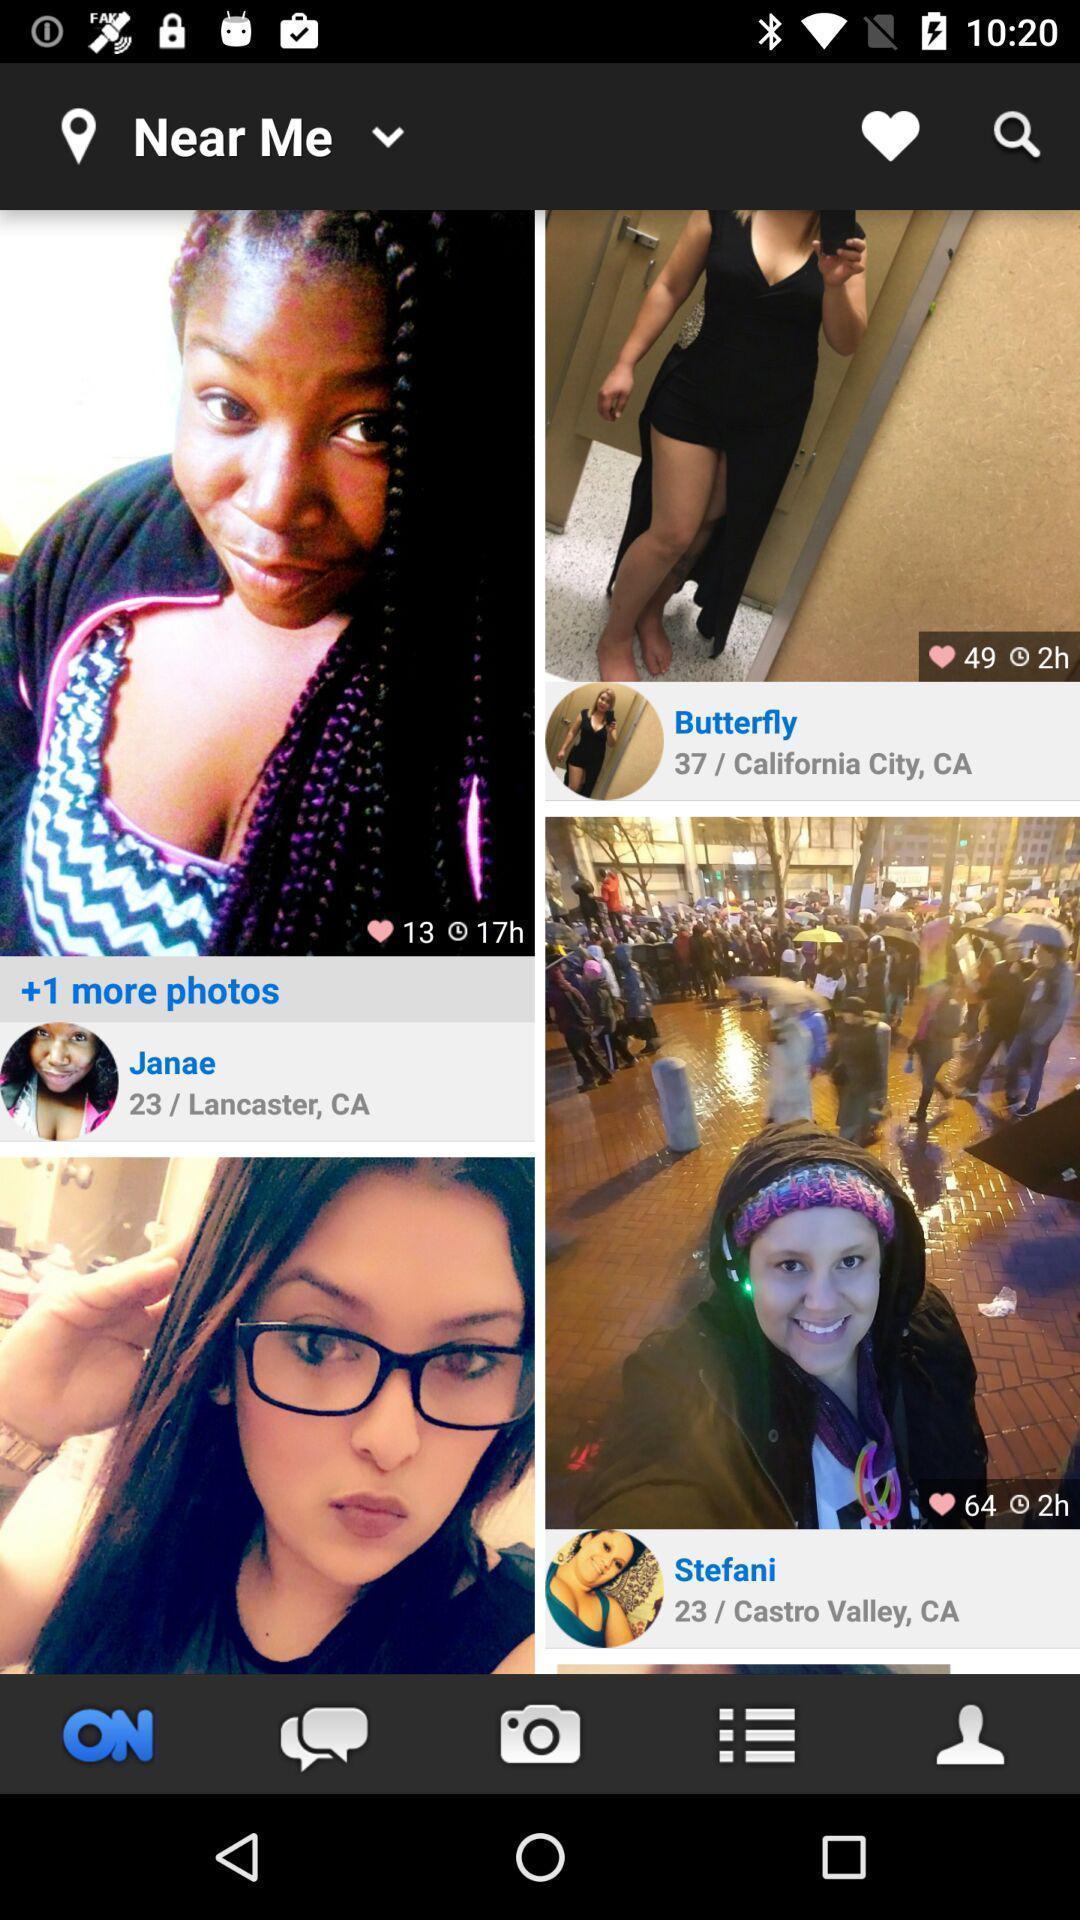Please provide a description for this image. Page showing various images. 